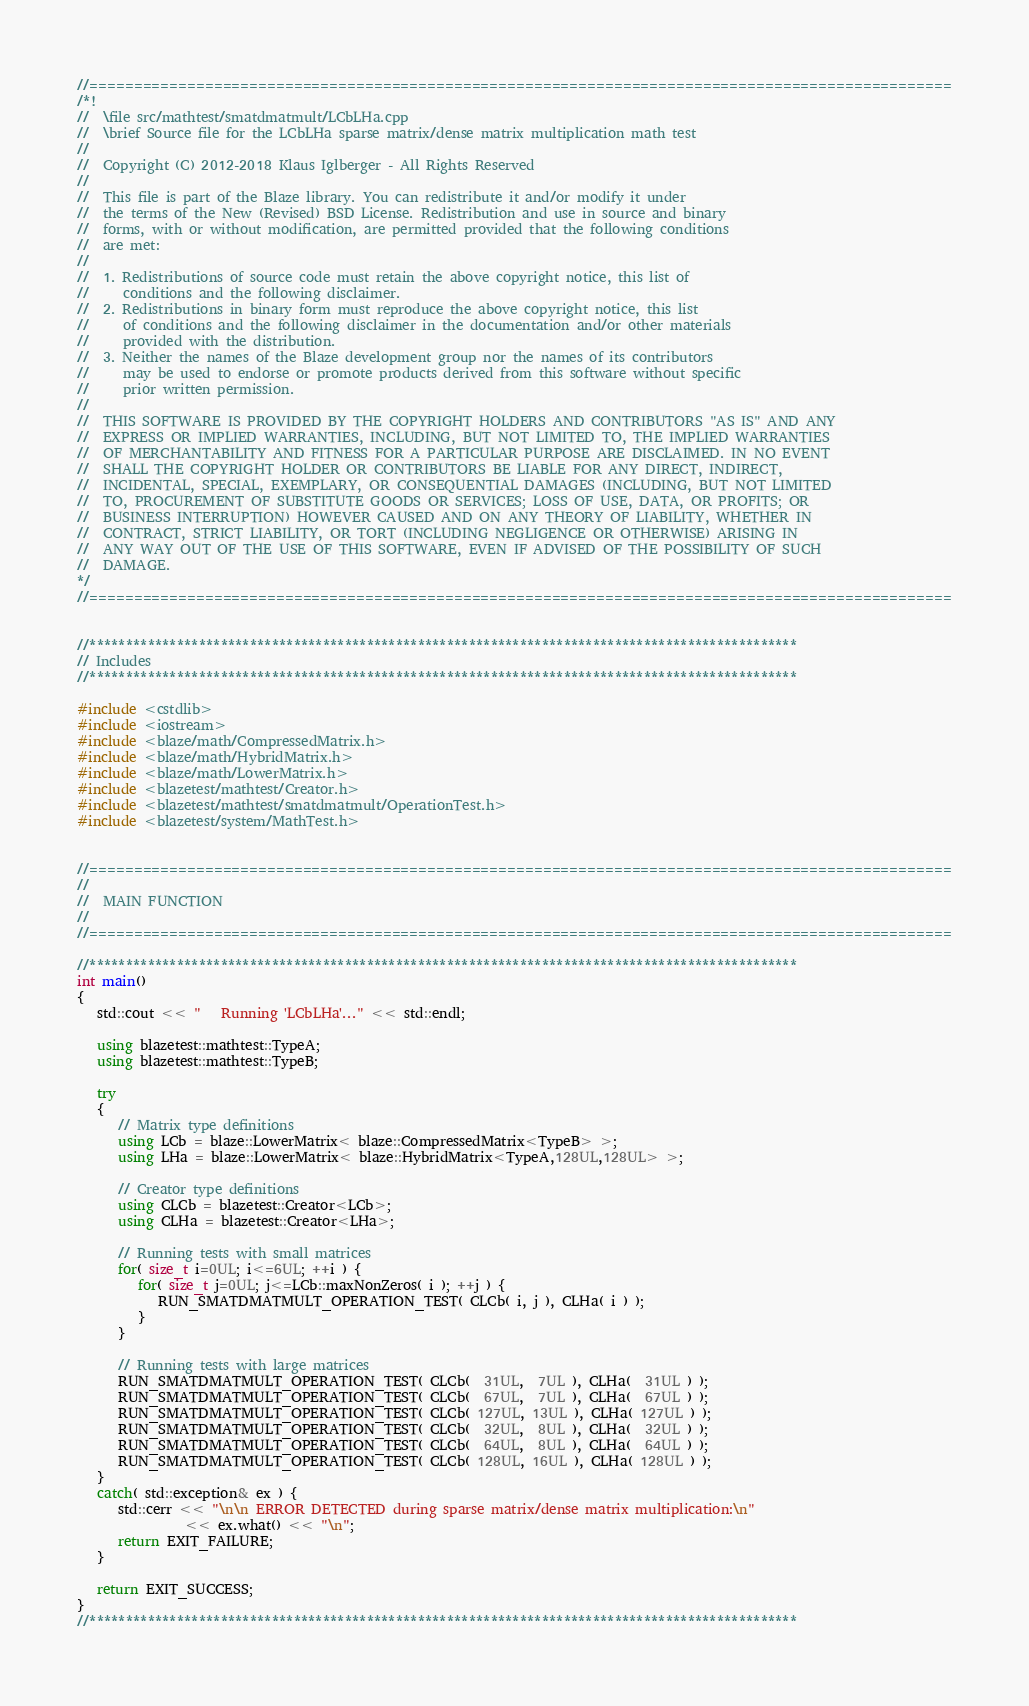Convert code to text. <code><loc_0><loc_0><loc_500><loc_500><_C++_>//=================================================================================================
/*!
//  \file src/mathtest/smatdmatmult/LCbLHa.cpp
//  \brief Source file for the LCbLHa sparse matrix/dense matrix multiplication math test
//
//  Copyright (C) 2012-2018 Klaus Iglberger - All Rights Reserved
//
//  This file is part of the Blaze library. You can redistribute it and/or modify it under
//  the terms of the New (Revised) BSD License. Redistribution and use in source and binary
//  forms, with or without modification, are permitted provided that the following conditions
//  are met:
//
//  1. Redistributions of source code must retain the above copyright notice, this list of
//     conditions and the following disclaimer.
//  2. Redistributions in binary form must reproduce the above copyright notice, this list
//     of conditions and the following disclaimer in the documentation and/or other materials
//     provided with the distribution.
//  3. Neither the names of the Blaze development group nor the names of its contributors
//     may be used to endorse or promote products derived from this software without specific
//     prior written permission.
//
//  THIS SOFTWARE IS PROVIDED BY THE COPYRIGHT HOLDERS AND CONTRIBUTORS "AS IS" AND ANY
//  EXPRESS OR IMPLIED WARRANTIES, INCLUDING, BUT NOT LIMITED TO, THE IMPLIED WARRANTIES
//  OF MERCHANTABILITY AND FITNESS FOR A PARTICULAR PURPOSE ARE DISCLAIMED. IN NO EVENT
//  SHALL THE COPYRIGHT HOLDER OR CONTRIBUTORS BE LIABLE FOR ANY DIRECT, INDIRECT,
//  INCIDENTAL, SPECIAL, EXEMPLARY, OR CONSEQUENTIAL DAMAGES (INCLUDING, BUT NOT LIMITED
//  TO, PROCUREMENT OF SUBSTITUTE GOODS OR SERVICES; LOSS OF USE, DATA, OR PROFITS; OR
//  BUSINESS INTERRUPTION) HOWEVER CAUSED AND ON ANY THEORY OF LIABILITY, WHETHER IN
//  CONTRACT, STRICT LIABILITY, OR TORT (INCLUDING NEGLIGENCE OR OTHERWISE) ARISING IN
//  ANY WAY OUT OF THE USE OF THIS SOFTWARE, EVEN IF ADVISED OF THE POSSIBILITY OF SUCH
//  DAMAGE.
*/
//=================================================================================================


//*************************************************************************************************
// Includes
//*************************************************************************************************

#include <cstdlib>
#include <iostream>
#include <blaze/math/CompressedMatrix.h>
#include <blaze/math/HybridMatrix.h>
#include <blaze/math/LowerMatrix.h>
#include <blazetest/mathtest/Creator.h>
#include <blazetest/mathtest/smatdmatmult/OperationTest.h>
#include <blazetest/system/MathTest.h>


//=================================================================================================
//
//  MAIN FUNCTION
//
//=================================================================================================

//*************************************************************************************************
int main()
{
   std::cout << "   Running 'LCbLHa'..." << std::endl;

   using blazetest::mathtest::TypeA;
   using blazetest::mathtest::TypeB;

   try
   {
      // Matrix type definitions
      using LCb = blaze::LowerMatrix< blaze::CompressedMatrix<TypeB> >;
      using LHa = blaze::LowerMatrix< blaze::HybridMatrix<TypeA,128UL,128UL> >;

      // Creator type definitions
      using CLCb = blazetest::Creator<LCb>;
      using CLHa = blazetest::Creator<LHa>;

      // Running tests with small matrices
      for( size_t i=0UL; i<=6UL; ++i ) {
         for( size_t j=0UL; j<=LCb::maxNonZeros( i ); ++j ) {
            RUN_SMATDMATMULT_OPERATION_TEST( CLCb( i, j ), CLHa( i ) );
         }
      }

      // Running tests with large matrices
      RUN_SMATDMATMULT_OPERATION_TEST( CLCb(  31UL,  7UL ), CLHa(  31UL ) );
      RUN_SMATDMATMULT_OPERATION_TEST( CLCb(  67UL,  7UL ), CLHa(  67UL ) );
      RUN_SMATDMATMULT_OPERATION_TEST( CLCb( 127UL, 13UL ), CLHa( 127UL ) );
      RUN_SMATDMATMULT_OPERATION_TEST( CLCb(  32UL,  8UL ), CLHa(  32UL ) );
      RUN_SMATDMATMULT_OPERATION_TEST( CLCb(  64UL,  8UL ), CLHa(  64UL ) );
      RUN_SMATDMATMULT_OPERATION_TEST( CLCb( 128UL, 16UL ), CLHa( 128UL ) );
   }
   catch( std::exception& ex ) {
      std::cerr << "\n\n ERROR DETECTED during sparse matrix/dense matrix multiplication:\n"
                << ex.what() << "\n";
      return EXIT_FAILURE;
   }

   return EXIT_SUCCESS;
}
//*************************************************************************************************
</code> 